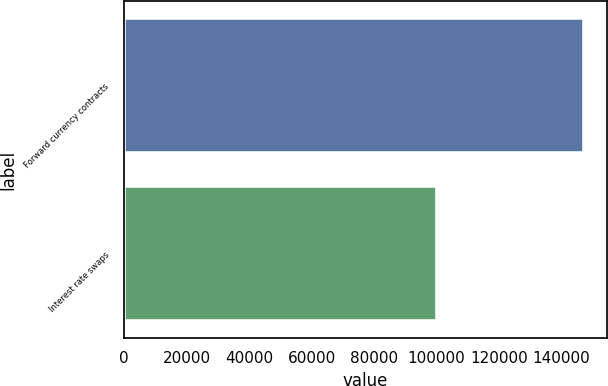Convert chart. <chart><loc_0><loc_0><loc_500><loc_500><bar_chart><fcel>Forward currency contracts<fcel>Interest rate swaps<nl><fcel>147078<fcel>100000<nl></chart> 